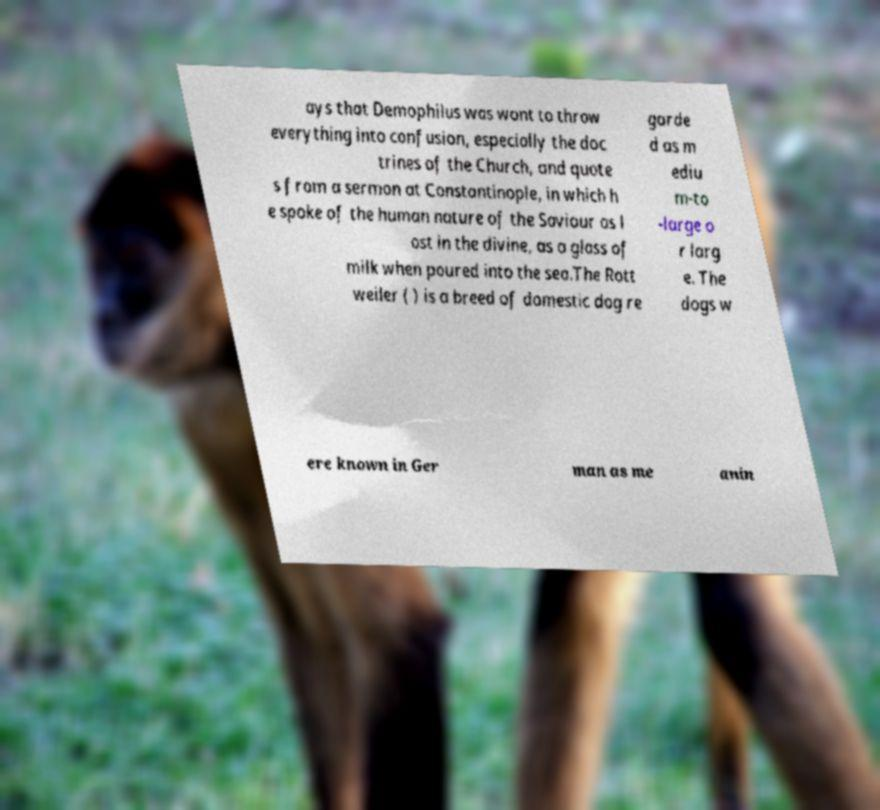What messages or text are displayed in this image? I need them in a readable, typed format. ays that Demophilus was wont to throw everything into confusion, especially the doc trines of the Church, and quote s from a sermon at Constantinople, in which h e spoke of the human nature of the Saviour as l ost in the divine, as a glass of milk when poured into the sea.The Rott weiler ( ) is a breed of domestic dog re garde d as m ediu m-to -large o r larg e. The dogs w ere known in Ger man as me anin 